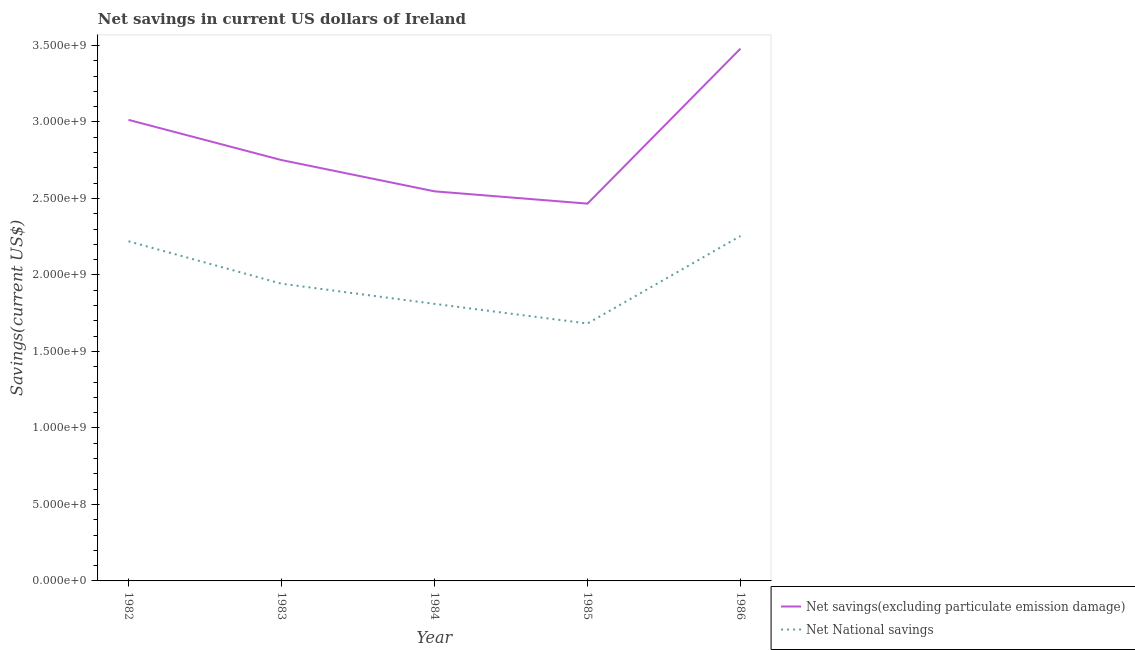How many different coloured lines are there?
Offer a terse response. 2. Is the number of lines equal to the number of legend labels?
Your answer should be compact. Yes. What is the net savings(excluding particulate emission damage) in 1984?
Keep it short and to the point. 2.55e+09. Across all years, what is the maximum net national savings?
Offer a very short reply. 2.25e+09. Across all years, what is the minimum net national savings?
Make the answer very short. 1.68e+09. What is the total net national savings in the graph?
Provide a short and direct response. 9.91e+09. What is the difference between the net national savings in 1983 and that in 1984?
Ensure brevity in your answer.  1.32e+08. What is the difference between the net savings(excluding particulate emission damage) in 1982 and the net national savings in 1984?
Offer a very short reply. 1.20e+09. What is the average net savings(excluding particulate emission damage) per year?
Make the answer very short. 2.85e+09. In the year 1984, what is the difference between the net national savings and net savings(excluding particulate emission damage)?
Your answer should be very brief. -7.36e+08. In how many years, is the net national savings greater than 3400000000 US$?
Provide a short and direct response. 0. What is the ratio of the net national savings in 1982 to that in 1984?
Make the answer very short. 1.23. Is the difference between the net savings(excluding particulate emission damage) in 1983 and 1986 greater than the difference between the net national savings in 1983 and 1986?
Offer a terse response. No. What is the difference between the highest and the second highest net national savings?
Your answer should be very brief. 3.46e+07. What is the difference between the highest and the lowest net national savings?
Provide a succinct answer. 5.72e+08. Is the net national savings strictly greater than the net savings(excluding particulate emission damage) over the years?
Make the answer very short. No. How many lines are there?
Provide a short and direct response. 2. How many years are there in the graph?
Offer a terse response. 5. Does the graph contain grids?
Make the answer very short. No. Where does the legend appear in the graph?
Offer a terse response. Bottom right. How many legend labels are there?
Offer a terse response. 2. What is the title of the graph?
Keep it short and to the point. Net savings in current US dollars of Ireland. Does "International Tourists" appear as one of the legend labels in the graph?
Give a very brief answer. No. What is the label or title of the Y-axis?
Your answer should be very brief. Savings(current US$). What is the Savings(current US$) in Net savings(excluding particulate emission damage) in 1982?
Your answer should be very brief. 3.01e+09. What is the Savings(current US$) in Net National savings in 1982?
Give a very brief answer. 2.22e+09. What is the Savings(current US$) of Net savings(excluding particulate emission damage) in 1983?
Ensure brevity in your answer.  2.75e+09. What is the Savings(current US$) in Net National savings in 1983?
Give a very brief answer. 1.94e+09. What is the Savings(current US$) of Net savings(excluding particulate emission damage) in 1984?
Make the answer very short. 2.55e+09. What is the Savings(current US$) in Net National savings in 1984?
Your response must be concise. 1.81e+09. What is the Savings(current US$) in Net savings(excluding particulate emission damage) in 1985?
Offer a terse response. 2.47e+09. What is the Savings(current US$) of Net National savings in 1985?
Keep it short and to the point. 1.68e+09. What is the Savings(current US$) of Net savings(excluding particulate emission damage) in 1986?
Ensure brevity in your answer.  3.48e+09. What is the Savings(current US$) of Net National savings in 1986?
Offer a terse response. 2.25e+09. Across all years, what is the maximum Savings(current US$) in Net savings(excluding particulate emission damage)?
Your answer should be compact. 3.48e+09. Across all years, what is the maximum Savings(current US$) of Net National savings?
Provide a short and direct response. 2.25e+09. Across all years, what is the minimum Savings(current US$) of Net savings(excluding particulate emission damage)?
Your answer should be very brief. 2.47e+09. Across all years, what is the minimum Savings(current US$) in Net National savings?
Provide a succinct answer. 1.68e+09. What is the total Savings(current US$) in Net savings(excluding particulate emission damage) in the graph?
Keep it short and to the point. 1.43e+1. What is the total Savings(current US$) of Net National savings in the graph?
Make the answer very short. 9.91e+09. What is the difference between the Savings(current US$) of Net savings(excluding particulate emission damage) in 1982 and that in 1983?
Make the answer very short. 2.63e+08. What is the difference between the Savings(current US$) in Net National savings in 1982 and that in 1983?
Your answer should be compact. 2.77e+08. What is the difference between the Savings(current US$) of Net savings(excluding particulate emission damage) in 1982 and that in 1984?
Keep it short and to the point. 4.67e+08. What is the difference between the Savings(current US$) in Net National savings in 1982 and that in 1984?
Provide a short and direct response. 4.09e+08. What is the difference between the Savings(current US$) in Net savings(excluding particulate emission damage) in 1982 and that in 1985?
Provide a succinct answer. 5.48e+08. What is the difference between the Savings(current US$) of Net National savings in 1982 and that in 1985?
Your answer should be very brief. 5.37e+08. What is the difference between the Savings(current US$) in Net savings(excluding particulate emission damage) in 1982 and that in 1986?
Your answer should be very brief. -4.65e+08. What is the difference between the Savings(current US$) of Net National savings in 1982 and that in 1986?
Keep it short and to the point. -3.46e+07. What is the difference between the Savings(current US$) of Net savings(excluding particulate emission damage) in 1983 and that in 1984?
Your response must be concise. 2.04e+08. What is the difference between the Savings(current US$) of Net National savings in 1983 and that in 1984?
Keep it short and to the point. 1.32e+08. What is the difference between the Savings(current US$) in Net savings(excluding particulate emission damage) in 1983 and that in 1985?
Your answer should be very brief. 2.85e+08. What is the difference between the Savings(current US$) in Net National savings in 1983 and that in 1985?
Give a very brief answer. 2.60e+08. What is the difference between the Savings(current US$) of Net savings(excluding particulate emission damage) in 1983 and that in 1986?
Ensure brevity in your answer.  -7.28e+08. What is the difference between the Savings(current US$) of Net National savings in 1983 and that in 1986?
Ensure brevity in your answer.  -3.12e+08. What is the difference between the Savings(current US$) of Net savings(excluding particulate emission damage) in 1984 and that in 1985?
Keep it short and to the point. 8.04e+07. What is the difference between the Savings(current US$) of Net National savings in 1984 and that in 1985?
Provide a short and direct response. 1.28e+08. What is the difference between the Savings(current US$) of Net savings(excluding particulate emission damage) in 1984 and that in 1986?
Make the answer very short. -9.33e+08. What is the difference between the Savings(current US$) in Net National savings in 1984 and that in 1986?
Provide a short and direct response. -4.44e+08. What is the difference between the Savings(current US$) in Net savings(excluding particulate emission damage) in 1985 and that in 1986?
Offer a terse response. -1.01e+09. What is the difference between the Savings(current US$) in Net National savings in 1985 and that in 1986?
Offer a terse response. -5.72e+08. What is the difference between the Savings(current US$) in Net savings(excluding particulate emission damage) in 1982 and the Savings(current US$) in Net National savings in 1983?
Ensure brevity in your answer.  1.07e+09. What is the difference between the Savings(current US$) of Net savings(excluding particulate emission damage) in 1982 and the Savings(current US$) of Net National savings in 1984?
Your answer should be very brief. 1.20e+09. What is the difference between the Savings(current US$) in Net savings(excluding particulate emission damage) in 1982 and the Savings(current US$) in Net National savings in 1985?
Provide a succinct answer. 1.33e+09. What is the difference between the Savings(current US$) of Net savings(excluding particulate emission damage) in 1982 and the Savings(current US$) of Net National savings in 1986?
Keep it short and to the point. 7.59e+08. What is the difference between the Savings(current US$) in Net savings(excluding particulate emission damage) in 1983 and the Savings(current US$) in Net National savings in 1984?
Your response must be concise. 9.40e+08. What is the difference between the Savings(current US$) of Net savings(excluding particulate emission damage) in 1983 and the Savings(current US$) of Net National savings in 1985?
Your answer should be compact. 1.07e+09. What is the difference between the Savings(current US$) in Net savings(excluding particulate emission damage) in 1983 and the Savings(current US$) in Net National savings in 1986?
Offer a terse response. 4.96e+08. What is the difference between the Savings(current US$) of Net savings(excluding particulate emission damage) in 1984 and the Savings(current US$) of Net National savings in 1985?
Offer a terse response. 8.64e+08. What is the difference between the Savings(current US$) of Net savings(excluding particulate emission damage) in 1984 and the Savings(current US$) of Net National savings in 1986?
Give a very brief answer. 2.92e+08. What is the difference between the Savings(current US$) in Net savings(excluding particulate emission damage) in 1985 and the Savings(current US$) in Net National savings in 1986?
Offer a very short reply. 2.12e+08. What is the average Savings(current US$) of Net savings(excluding particulate emission damage) per year?
Your response must be concise. 2.85e+09. What is the average Savings(current US$) of Net National savings per year?
Ensure brevity in your answer.  1.98e+09. In the year 1982, what is the difference between the Savings(current US$) of Net savings(excluding particulate emission damage) and Savings(current US$) of Net National savings?
Your answer should be very brief. 7.94e+08. In the year 1983, what is the difference between the Savings(current US$) of Net savings(excluding particulate emission damage) and Savings(current US$) of Net National savings?
Make the answer very short. 8.08e+08. In the year 1984, what is the difference between the Savings(current US$) of Net savings(excluding particulate emission damage) and Savings(current US$) of Net National savings?
Your answer should be very brief. 7.36e+08. In the year 1985, what is the difference between the Savings(current US$) of Net savings(excluding particulate emission damage) and Savings(current US$) of Net National savings?
Provide a succinct answer. 7.83e+08. In the year 1986, what is the difference between the Savings(current US$) of Net savings(excluding particulate emission damage) and Savings(current US$) of Net National savings?
Offer a very short reply. 1.22e+09. What is the ratio of the Savings(current US$) in Net savings(excluding particulate emission damage) in 1982 to that in 1983?
Offer a very short reply. 1.1. What is the ratio of the Savings(current US$) of Net National savings in 1982 to that in 1983?
Give a very brief answer. 1.14. What is the ratio of the Savings(current US$) in Net savings(excluding particulate emission damage) in 1982 to that in 1984?
Keep it short and to the point. 1.18. What is the ratio of the Savings(current US$) of Net National savings in 1982 to that in 1984?
Your answer should be very brief. 1.23. What is the ratio of the Savings(current US$) of Net savings(excluding particulate emission damage) in 1982 to that in 1985?
Provide a short and direct response. 1.22. What is the ratio of the Savings(current US$) in Net National savings in 1982 to that in 1985?
Keep it short and to the point. 1.32. What is the ratio of the Savings(current US$) of Net savings(excluding particulate emission damage) in 1982 to that in 1986?
Provide a succinct answer. 0.87. What is the ratio of the Savings(current US$) of Net National savings in 1982 to that in 1986?
Offer a very short reply. 0.98. What is the ratio of the Savings(current US$) of Net savings(excluding particulate emission damage) in 1983 to that in 1984?
Your answer should be compact. 1.08. What is the ratio of the Savings(current US$) in Net National savings in 1983 to that in 1984?
Offer a very short reply. 1.07. What is the ratio of the Savings(current US$) of Net savings(excluding particulate emission damage) in 1983 to that in 1985?
Provide a succinct answer. 1.12. What is the ratio of the Savings(current US$) of Net National savings in 1983 to that in 1985?
Offer a terse response. 1.15. What is the ratio of the Savings(current US$) in Net savings(excluding particulate emission damage) in 1983 to that in 1986?
Offer a very short reply. 0.79. What is the ratio of the Savings(current US$) in Net National savings in 1983 to that in 1986?
Offer a very short reply. 0.86. What is the ratio of the Savings(current US$) of Net savings(excluding particulate emission damage) in 1984 to that in 1985?
Offer a terse response. 1.03. What is the ratio of the Savings(current US$) of Net National savings in 1984 to that in 1985?
Keep it short and to the point. 1.08. What is the ratio of the Savings(current US$) of Net savings(excluding particulate emission damage) in 1984 to that in 1986?
Make the answer very short. 0.73. What is the ratio of the Savings(current US$) in Net National savings in 1984 to that in 1986?
Make the answer very short. 0.8. What is the ratio of the Savings(current US$) of Net savings(excluding particulate emission damage) in 1985 to that in 1986?
Your answer should be compact. 0.71. What is the ratio of the Savings(current US$) of Net National savings in 1985 to that in 1986?
Make the answer very short. 0.75. What is the difference between the highest and the second highest Savings(current US$) of Net savings(excluding particulate emission damage)?
Keep it short and to the point. 4.65e+08. What is the difference between the highest and the second highest Savings(current US$) in Net National savings?
Your answer should be compact. 3.46e+07. What is the difference between the highest and the lowest Savings(current US$) in Net savings(excluding particulate emission damage)?
Your answer should be compact. 1.01e+09. What is the difference between the highest and the lowest Savings(current US$) in Net National savings?
Provide a succinct answer. 5.72e+08. 